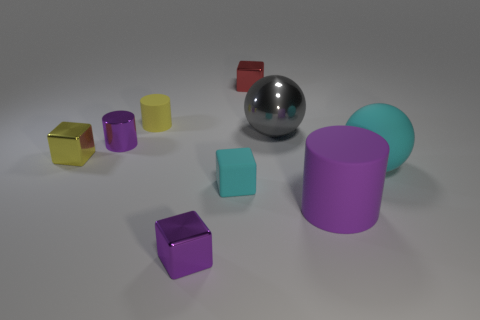There is a purple block; is its size the same as the purple cylinder that is right of the tiny purple cylinder? No, the sizes differ. The purple block is smaller in volume when compared to the purple cylinder situated to the right of the tiny purple cylinder. 